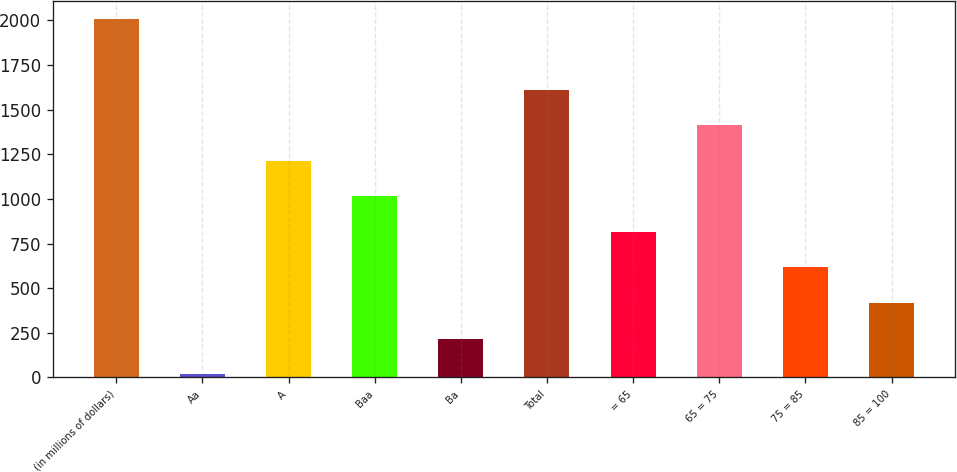Convert chart. <chart><loc_0><loc_0><loc_500><loc_500><bar_chart><fcel>(in millions of dollars)<fcel>Aa<fcel>A<fcel>Baa<fcel>Ba<fcel>Total<fcel>= 65<fcel>65 = 75<fcel>75 = 85<fcel>85 = 100<nl><fcel>2010<fcel>19<fcel>1213.6<fcel>1014.5<fcel>218.1<fcel>1611.8<fcel>815.4<fcel>1412.7<fcel>616.3<fcel>417.2<nl></chart> 